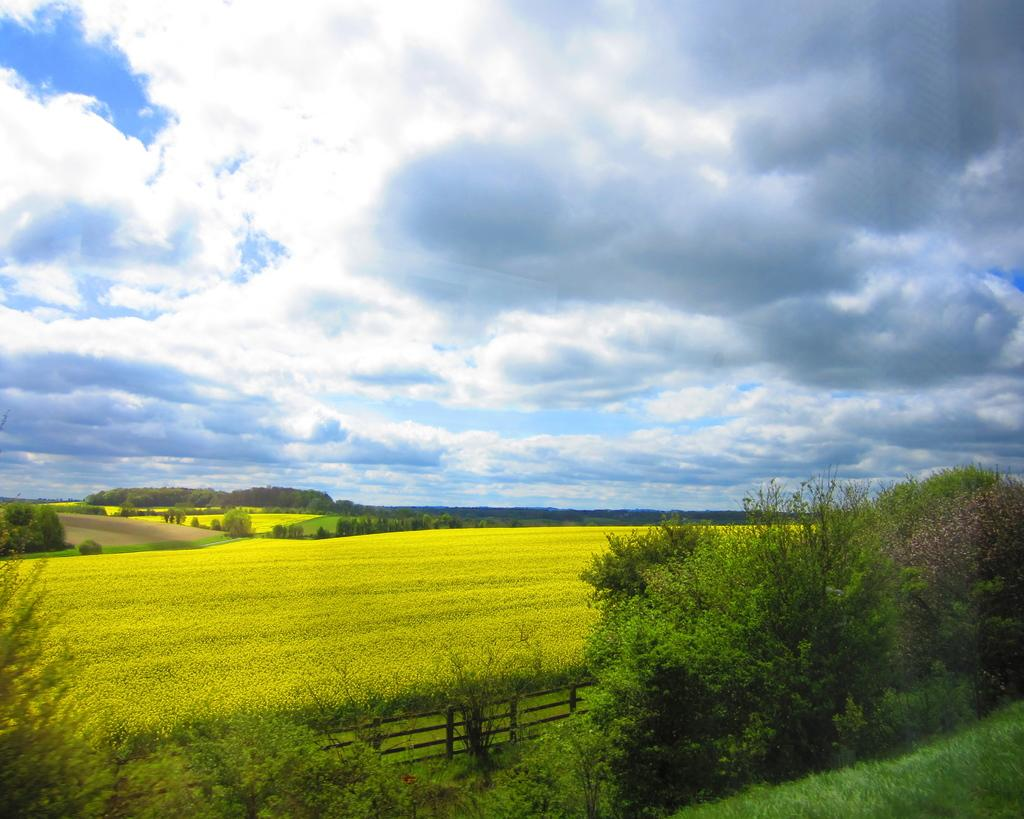What is the condition of the sky in the image? The sky is cloudy in the image. What type of vegetation covers the land in the image? The land is covered with grass in the image. What can be seen in the distance in the image? There are trees in the distance in the image. What other type of vegetation is visible in the image? There are plants visible in the image. What type of barrier is present in the image? There is a fence in the image. How many beans are growing on the fence in the image? There are no beans growing on the fence in the image; it is a fence, not a plant. What type of fish can be seen swimming in the grass in the image? There are no fish present in the image, and grass is not a suitable environment for fish. 